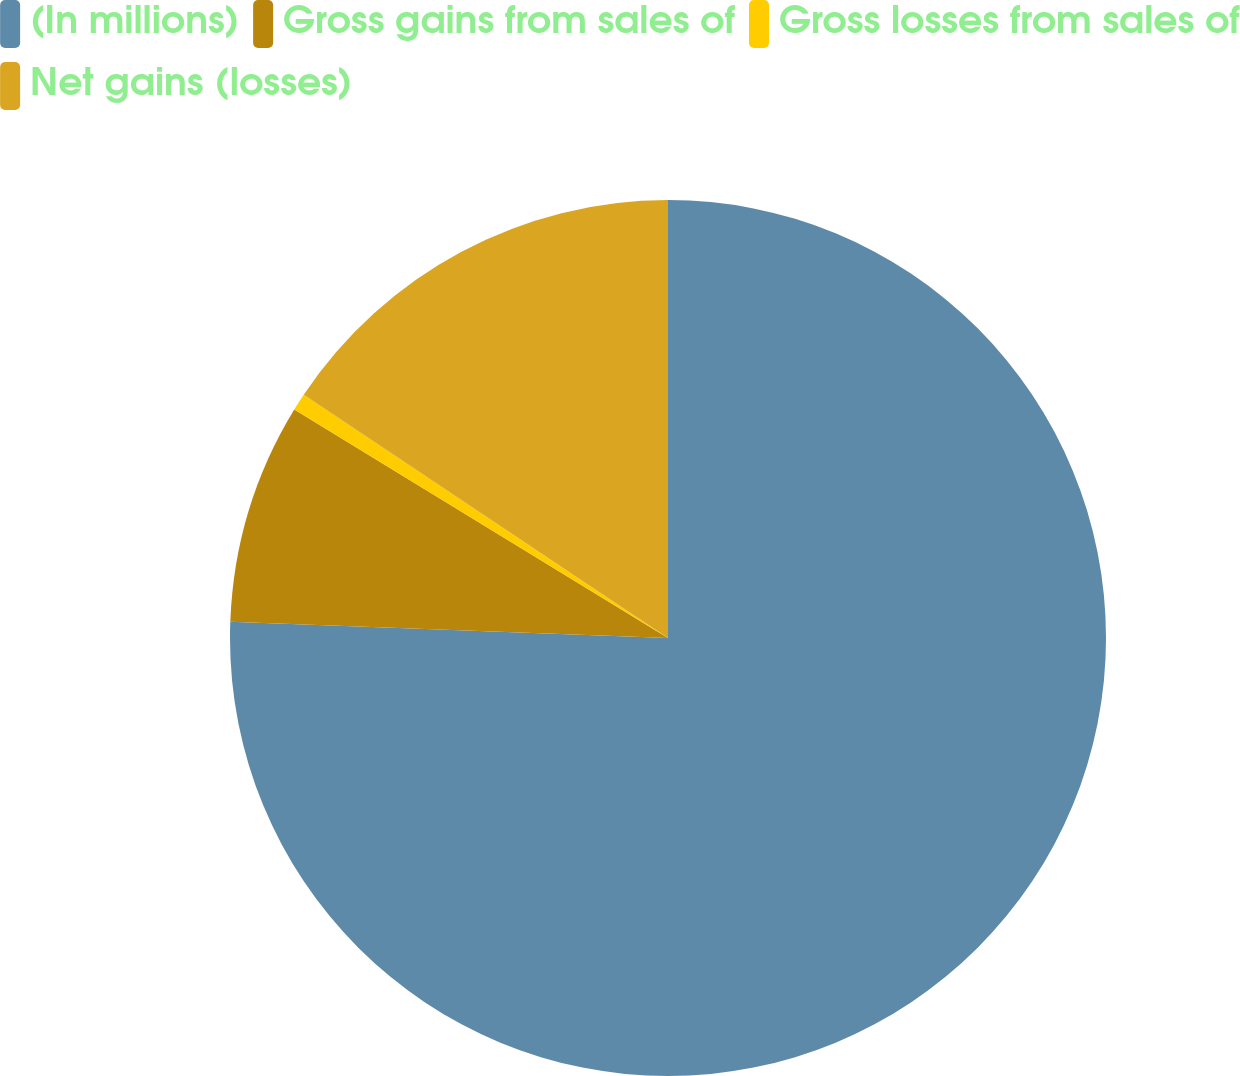Convert chart to OTSL. <chart><loc_0><loc_0><loc_500><loc_500><pie_chart><fcel>(In millions)<fcel>Gross gains from sales of<fcel>Gross losses from sales of<fcel>Net gains (losses)<nl><fcel>75.59%<fcel>8.14%<fcel>0.64%<fcel>15.63%<nl></chart> 